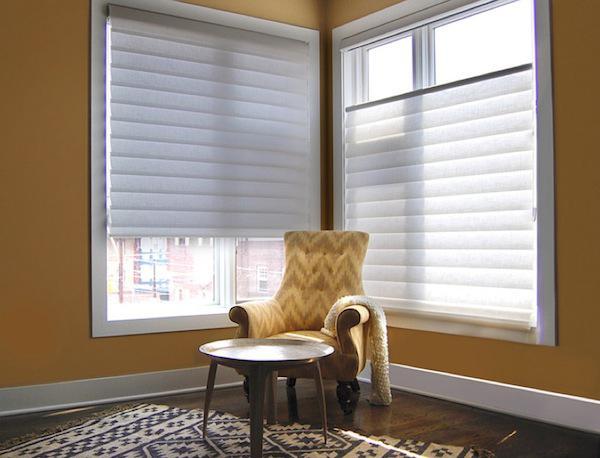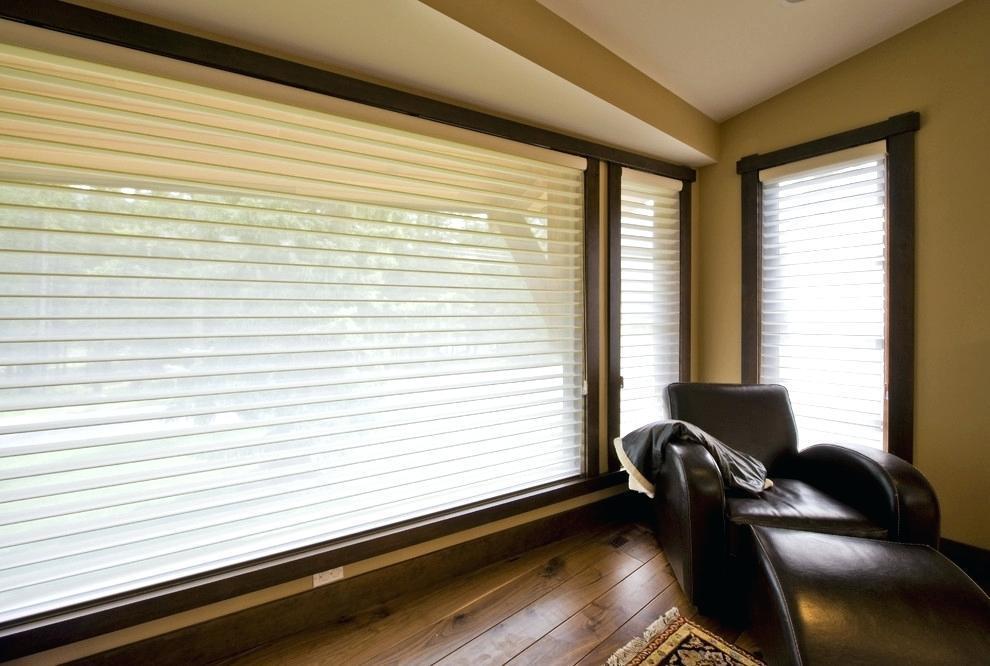The first image is the image on the left, the second image is the image on the right. For the images displayed, is the sentence "There are no less than five blinds." factually correct? Answer yes or no. Yes. The first image is the image on the left, the second image is the image on the right. Given the left and right images, does the statement "There is a bed in front of a nature backdrop." hold true? Answer yes or no. No. 